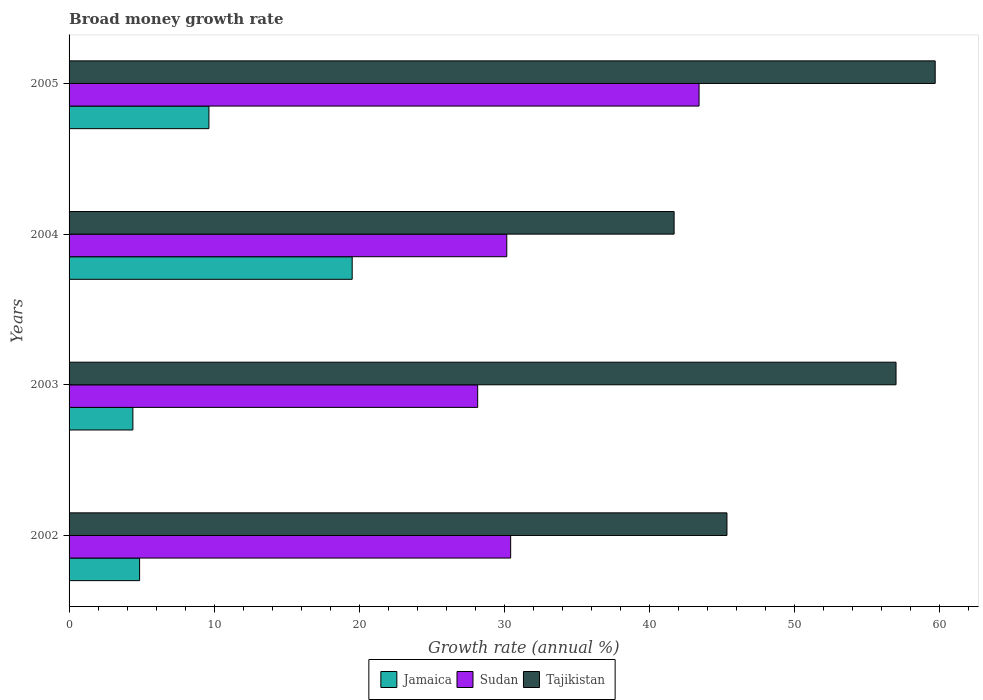How many groups of bars are there?
Make the answer very short. 4. Are the number of bars on each tick of the Y-axis equal?
Keep it short and to the point. Yes. How many bars are there on the 4th tick from the top?
Ensure brevity in your answer.  3. How many bars are there on the 4th tick from the bottom?
Offer a very short reply. 3. What is the label of the 2nd group of bars from the top?
Offer a very short reply. 2004. In how many cases, is the number of bars for a given year not equal to the number of legend labels?
Make the answer very short. 0. What is the growth rate in Tajikistan in 2004?
Keep it short and to the point. 41.7. Across all years, what is the maximum growth rate in Jamaica?
Provide a short and direct response. 19.51. Across all years, what is the minimum growth rate in Sudan?
Give a very brief answer. 28.16. In which year was the growth rate in Sudan minimum?
Keep it short and to the point. 2003. What is the total growth rate in Tajikistan in the graph?
Provide a short and direct response. 203.72. What is the difference between the growth rate in Jamaica in 2002 and that in 2003?
Your answer should be compact. 0.46. What is the difference between the growth rate in Jamaica in 2004 and the growth rate in Sudan in 2002?
Make the answer very short. -10.92. What is the average growth rate in Sudan per year?
Make the answer very short. 33.04. In the year 2005, what is the difference between the growth rate in Tajikistan and growth rate in Sudan?
Your answer should be compact. 16.27. What is the ratio of the growth rate in Tajikistan in 2002 to that in 2005?
Your answer should be very brief. 0.76. Is the growth rate in Sudan in 2002 less than that in 2004?
Give a very brief answer. No. What is the difference between the highest and the second highest growth rate in Jamaica?
Your response must be concise. 9.87. What is the difference between the highest and the lowest growth rate in Sudan?
Offer a very short reply. 15.26. What does the 2nd bar from the top in 2005 represents?
Provide a short and direct response. Sudan. What does the 1st bar from the bottom in 2004 represents?
Give a very brief answer. Jamaica. Is it the case that in every year, the sum of the growth rate in Tajikistan and growth rate in Jamaica is greater than the growth rate in Sudan?
Offer a terse response. Yes. Are all the bars in the graph horizontal?
Your answer should be very brief. Yes. What is the difference between two consecutive major ticks on the X-axis?
Keep it short and to the point. 10. Are the values on the major ticks of X-axis written in scientific E-notation?
Your response must be concise. No. Does the graph contain grids?
Your answer should be compact. No. What is the title of the graph?
Give a very brief answer. Broad money growth rate. What is the label or title of the X-axis?
Offer a very short reply. Growth rate (annual %). What is the Growth rate (annual %) in Jamaica in 2002?
Keep it short and to the point. 4.86. What is the Growth rate (annual %) in Sudan in 2002?
Provide a short and direct response. 30.43. What is the Growth rate (annual %) of Tajikistan in 2002?
Give a very brief answer. 45.34. What is the Growth rate (annual %) of Jamaica in 2003?
Your answer should be very brief. 4.4. What is the Growth rate (annual %) in Sudan in 2003?
Offer a terse response. 28.16. What is the Growth rate (annual %) of Tajikistan in 2003?
Make the answer very short. 56.99. What is the Growth rate (annual %) of Jamaica in 2004?
Your response must be concise. 19.51. What is the Growth rate (annual %) of Sudan in 2004?
Give a very brief answer. 30.17. What is the Growth rate (annual %) in Tajikistan in 2004?
Give a very brief answer. 41.7. What is the Growth rate (annual %) of Jamaica in 2005?
Offer a terse response. 9.64. What is the Growth rate (annual %) in Sudan in 2005?
Offer a terse response. 43.42. What is the Growth rate (annual %) of Tajikistan in 2005?
Ensure brevity in your answer.  59.69. Across all years, what is the maximum Growth rate (annual %) in Jamaica?
Provide a short and direct response. 19.51. Across all years, what is the maximum Growth rate (annual %) in Sudan?
Your answer should be very brief. 43.42. Across all years, what is the maximum Growth rate (annual %) of Tajikistan?
Your response must be concise. 59.69. Across all years, what is the minimum Growth rate (annual %) of Jamaica?
Your answer should be very brief. 4.4. Across all years, what is the minimum Growth rate (annual %) in Sudan?
Offer a very short reply. 28.16. Across all years, what is the minimum Growth rate (annual %) of Tajikistan?
Give a very brief answer. 41.7. What is the total Growth rate (annual %) of Jamaica in the graph?
Your response must be concise. 38.41. What is the total Growth rate (annual %) of Sudan in the graph?
Offer a very short reply. 132.18. What is the total Growth rate (annual %) in Tajikistan in the graph?
Provide a short and direct response. 203.72. What is the difference between the Growth rate (annual %) in Jamaica in 2002 and that in 2003?
Provide a short and direct response. 0.46. What is the difference between the Growth rate (annual %) in Sudan in 2002 and that in 2003?
Make the answer very short. 2.27. What is the difference between the Growth rate (annual %) of Tajikistan in 2002 and that in 2003?
Make the answer very short. -11.65. What is the difference between the Growth rate (annual %) of Jamaica in 2002 and that in 2004?
Your answer should be compact. -14.65. What is the difference between the Growth rate (annual %) in Sudan in 2002 and that in 2004?
Your response must be concise. 0.27. What is the difference between the Growth rate (annual %) of Tajikistan in 2002 and that in 2004?
Ensure brevity in your answer.  3.64. What is the difference between the Growth rate (annual %) of Jamaica in 2002 and that in 2005?
Offer a terse response. -4.78. What is the difference between the Growth rate (annual %) in Sudan in 2002 and that in 2005?
Offer a terse response. -12.98. What is the difference between the Growth rate (annual %) in Tajikistan in 2002 and that in 2005?
Give a very brief answer. -14.35. What is the difference between the Growth rate (annual %) of Jamaica in 2003 and that in 2004?
Your answer should be compact. -15.11. What is the difference between the Growth rate (annual %) in Sudan in 2003 and that in 2004?
Your answer should be very brief. -2.01. What is the difference between the Growth rate (annual %) in Tajikistan in 2003 and that in 2004?
Your answer should be compact. 15.29. What is the difference between the Growth rate (annual %) in Jamaica in 2003 and that in 2005?
Offer a terse response. -5.24. What is the difference between the Growth rate (annual %) of Sudan in 2003 and that in 2005?
Provide a succinct answer. -15.26. What is the difference between the Growth rate (annual %) of Tajikistan in 2003 and that in 2005?
Your answer should be very brief. -2.7. What is the difference between the Growth rate (annual %) of Jamaica in 2004 and that in 2005?
Offer a very short reply. 9.87. What is the difference between the Growth rate (annual %) in Sudan in 2004 and that in 2005?
Provide a short and direct response. -13.25. What is the difference between the Growth rate (annual %) in Tajikistan in 2004 and that in 2005?
Your answer should be very brief. -17.99. What is the difference between the Growth rate (annual %) of Jamaica in 2002 and the Growth rate (annual %) of Sudan in 2003?
Your answer should be very brief. -23.3. What is the difference between the Growth rate (annual %) of Jamaica in 2002 and the Growth rate (annual %) of Tajikistan in 2003?
Your answer should be very brief. -52.13. What is the difference between the Growth rate (annual %) in Sudan in 2002 and the Growth rate (annual %) in Tajikistan in 2003?
Your answer should be very brief. -26.56. What is the difference between the Growth rate (annual %) of Jamaica in 2002 and the Growth rate (annual %) of Sudan in 2004?
Give a very brief answer. -25.31. What is the difference between the Growth rate (annual %) in Jamaica in 2002 and the Growth rate (annual %) in Tajikistan in 2004?
Give a very brief answer. -36.84. What is the difference between the Growth rate (annual %) in Sudan in 2002 and the Growth rate (annual %) in Tajikistan in 2004?
Provide a succinct answer. -11.26. What is the difference between the Growth rate (annual %) of Jamaica in 2002 and the Growth rate (annual %) of Sudan in 2005?
Offer a very short reply. -38.56. What is the difference between the Growth rate (annual %) in Jamaica in 2002 and the Growth rate (annual %) in Tajikistan in 2005?
Give a very brief answer. -54.83. What is the difference between the Growth rate (annual %) in Sudan in 2002 and the Growth rate (annual %) in Tajikistan in 2005?
Your answer should be very brief. -29.26. What is the difference between the Growth rate (annual %) in Jamaica in 2003 and the Growth rate (annual %) in Sudan in 2004?
Provide a short and direct response. -25.77. What is the difference between the Growth rate (annual %) in Jamaica in 2003 and the Growth rate (annual %) in Tajikistan in 2004?
Offer a very short reply. -37.3. What is the difference between the Growth rate (annual %) in Sudan in 2003 and the Growth rate (annual %) in Tajikistan in 2004?
Keep it short and to the point. -13.54. What is the difference between the Growth rate (annual %) in Jamaica in 2003 and the Growth rate (annual %) in Sudan in 2005?
Keep it short and to the point. -39.02. What is the difference between the Growth rate (annual %) in Jamaica in 2003 and the Growth rate (annual %) in Tajikistan in 2005?
Your answer should be compact. -55.29. What is the difference between the Growth rate (annual %) in Sudan in 2003 and the Growth rate (annual %) in Tajikistan in 2005?
Your answer should be very brief. -31.53. What is the difference between the Growth rate (annual %) of Jamaica in 2004 and the Growth rate (annual %) of Sudan in 2005?
Keep it short and to the point. -23.91. What is the difference between the Growth rate (annual %) of Jamaica in 2004 and the Growth rate (annual %) of Tajikistan in 2005?
Your response must be concise. -40.18. What is the difference between the Growth rate (annual %) of Sudan in 2004 and the Growth rate (annual %) of Tajikistan in 2005?
Your response must be concise. -29.53. What is the average Growth rate (annual %) in Jamaica per year?
Ensure brevity in your answer.  9.6. What is the average Growth rate (annual %) in Sudan per year?
Keep it short and to the point. 33.04. What is the average Growth rate (annual %) in Tajikistan per year?
Keep it short and to the point. 50.93. In the year 2002, what is the difference between the Growth rate (annual %) in Jamaica and Growth rate (annual %) in Sudan?
Your answer should be compact. -25.57. In the year 2002, what is the difference between the Growth rate (annual %) of Jamaica and Growth rate (annual %) of Tajikistan?
Make the answer very short. -40.48. In the year 2002, what is the difference between the Growth rate (annual %) of Sudan and Growth rate (annual %) of Tajikistan?
Ensure brevity in your answer.  -14.91. In the year 2003, what is the difference between the Growth rate (annual %) in Jamaica and Growth rate (annual %) in Sudan?
Give a very brief answer. -23.76. In the year 2003, what is the difference between the Growth rate (annual %) in Jamaica and Growth rate (annual %) in Tajikistan?
Your answer should be compact. -52.59. In the year 2003, what is the difference between the Growth rate (annual %) of Sudan and Growth rate (annual %) of Tajikistan?
Keep it short and to the point. -28.83. In the year 2004, what is the difference between the Growth rate (annual %) in Jamaica and Growth rate (annual %) in Sudan?
Provide a succinct answer. -10.65. In the year 2004, what is the difference between the Growth rate (annual %) in Jamaica and Growth rate (annual %) in Tajikistan?
Keep it short and to the point. -22.19. In the year 2004, what is the difference between the Growth rate (annual %) in Sudan and Growth rate (annual %) in Tajikistan?
Your answer should be very brief. -11.53. In the year 2005, what is the difference between the Growth rate (annual %) in Jamaica and Growth rate (annual %) in Sudan?
Offer a very short reply. -33.78. In the year 2005, what is the difference between the Growth rate (annual %) in Jamaica and Growth rate (annual %) in Tajikistan?
Ensure brevity in your answer.  -50.05. In the year 2005, what is the difference between the Growth rate (annual %) in Sudan and Growth rate (annual %) in Tajikistan?
Ensure brevity in your answer.  -16.27. What is the ratio of the Growth rate (annual %) in Jamaica in 2002 to that in 2003?
Make the answer very short. 1.1. What is the ratio of the Growth rate (annual %) of Sudan in 2002 to that in 2003?
Give a very brief answer. 1.08. What is the ratio of the Growth rate (annual %) of Tajikistan in 2002 to that in 2003?
Your answer should be very brief. 0.8. What is the ratio of the Growth rate (annual %) of Jamaica in 2002 to that in 2004?
Provide a short and direct response. 0.25. What is the ratio of the Growth rate (annual %) in Sudan in 2002 to that in 2004?
Provide a short and direct response. 1.01. What is the ratio of the Growth rate (annual %) in Tajikistan in 2002 to that in 2004?
Your answer should be compact. 1.09. What is the ratio of the Growth rate (annual %) in Jamaica in 2002 to that in 2005?
Provide a short and direct response. 0.5. What is the ratio of the Growth rate (annual %) of Sudan in 2002 to that in 2005?
Ensure brevity in your answer.  0.7. What is the ratio of the Growth rate (annual %) in Tajikistan in 2002 to that in 2005?
Keep it short and to the point. 0.76. What is the ratio of the Growth rate (annual %) of Jamaica in 2003 to that in 2004?
Provide a short and direct response. 0.23. What is the ratio of the Growth rate (annual %) of Sudan in 2003 to that in 2004?
Provide a short and direct response. 0.93. What is the ratio of the Growth rate (annual %) in Tajikistan in 2003 to that in 2004?
Your answer should be very brief. 1.37. What is the ratio of the Growth rate (annual %) in Jamaica in 2003 to that in 2005?
Your answer should be very brief. 0.46. What is the ratio of the Growth rate (annual %) in Sudan in 2003 to that in 2005?
Offer a terse response. 0.65. What is the ratio of the Growth rate (annual %) of Tajikistan in 2003 to that in 2005?
Your answer should be very brief. 0.95. What is the ratio of the Growth rate (annual %) in Jamaica in 2004 to that in 2005?
Make the answer very short. 2.02. What is the ratio of the Growth rate (annual %) in Sudan in 2004 to that in 2005?
Your answer should be compact. 0.69. What is the ratio of the Growth rate (annual %) in Tajikistan in 2004 to that in 2005?
Offer a terse response. 0.7. What is the difference between the highest and the second highest Growth rate (annual %) of Jamaica?
Provide a succinct answer. 9.87. What is the difference between the highest and the second highest Growth rate (annual %) of Sudan?
Make the answer very short. 12.98. What is the difference between the highest and the second highest Growth rate (annual %) of Tajikistan?
Offer a terse response. 2.7. What is the difference between the highest and the lowest Growth rate (annual %) in Jamaica?
Make the answer very short. 15.11. What is the difference between the highest and the lowest Growth rate (annual %) of Sudan?
Keep it short and to the point. 15.26. What is the difference between the highest and the lowest Growth rate (annual %) of Tajikistan?
Your answer should be compact. 17.99. 